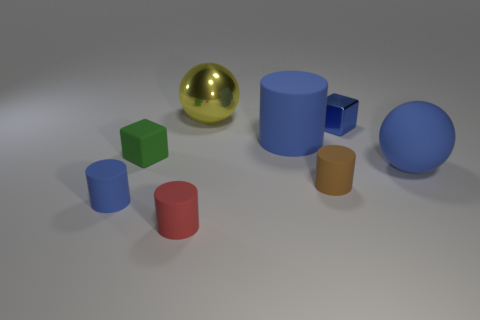The large thing that is the same color as the large rubber ball is what shape?
Provide a succinct answer. Cylinder. How big is the blue cylinder behind the blue matte cylinder that is to the left of the yellow metallic thing to the left of the small blue metal object?
Offer a terse response. Large. How many other things are there of the same shape as the large yellow thing?
Your answer should be compact. 1. There is a cube that is right of the green thing; does it have the same color as the object that is on the left side of the green rubber object?
Provide a short and direct response. Yes. The matte cylinder that is the same size as the yellow metallic sphere is what color?
Make the answer very short. Blue. Are there any tiny rubber objects that have the same color as the small metallic cube?
Your answer should be very brief. Yes. There is a cube right of the yellow metal sphere; is it the same size as the tiny brown matte cylinder?
Make the answer very short. Yes. Is the number of big blue cylinders that are behind the matte cube the same as the number of red rubber cylinders?
Make the answer very short. Yes. What number of things are either blue matte objects that are behind the small rubber cube or balls?
Provide a succinct answer. 3. There is a small matte object that is behind the tiny blue matte cylinder and to the left of the red rubber thing; what shape is it?
Offer a very short reply. Cube. 